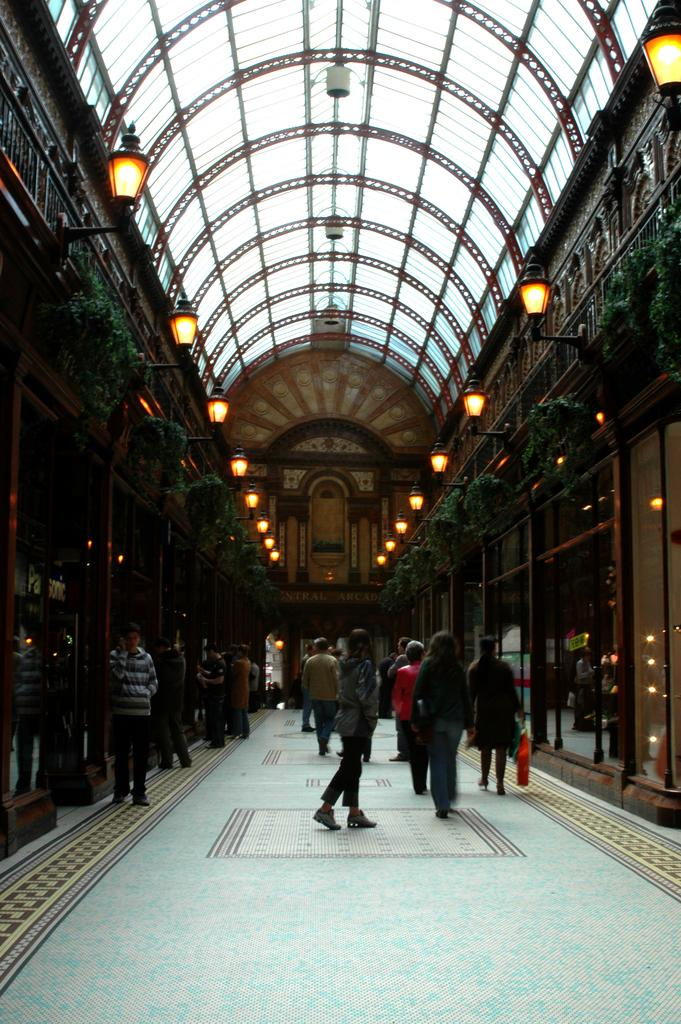Where was the image taken? The image is taken inside a building. What can be seen at the top of the image? There are lights visible at the top of the image. What is above the lights in the image? There is a roof visible in the image. What are the people in the image doing? There are people walking in the middle of the image. What type of walls can be seen on both sides of the image? There are glass walls on both sides of the image. How does the building change its appearance throughout the day in the image? The image does not show the building changing its appearance throughout the day; it is a static representation of the scene. 